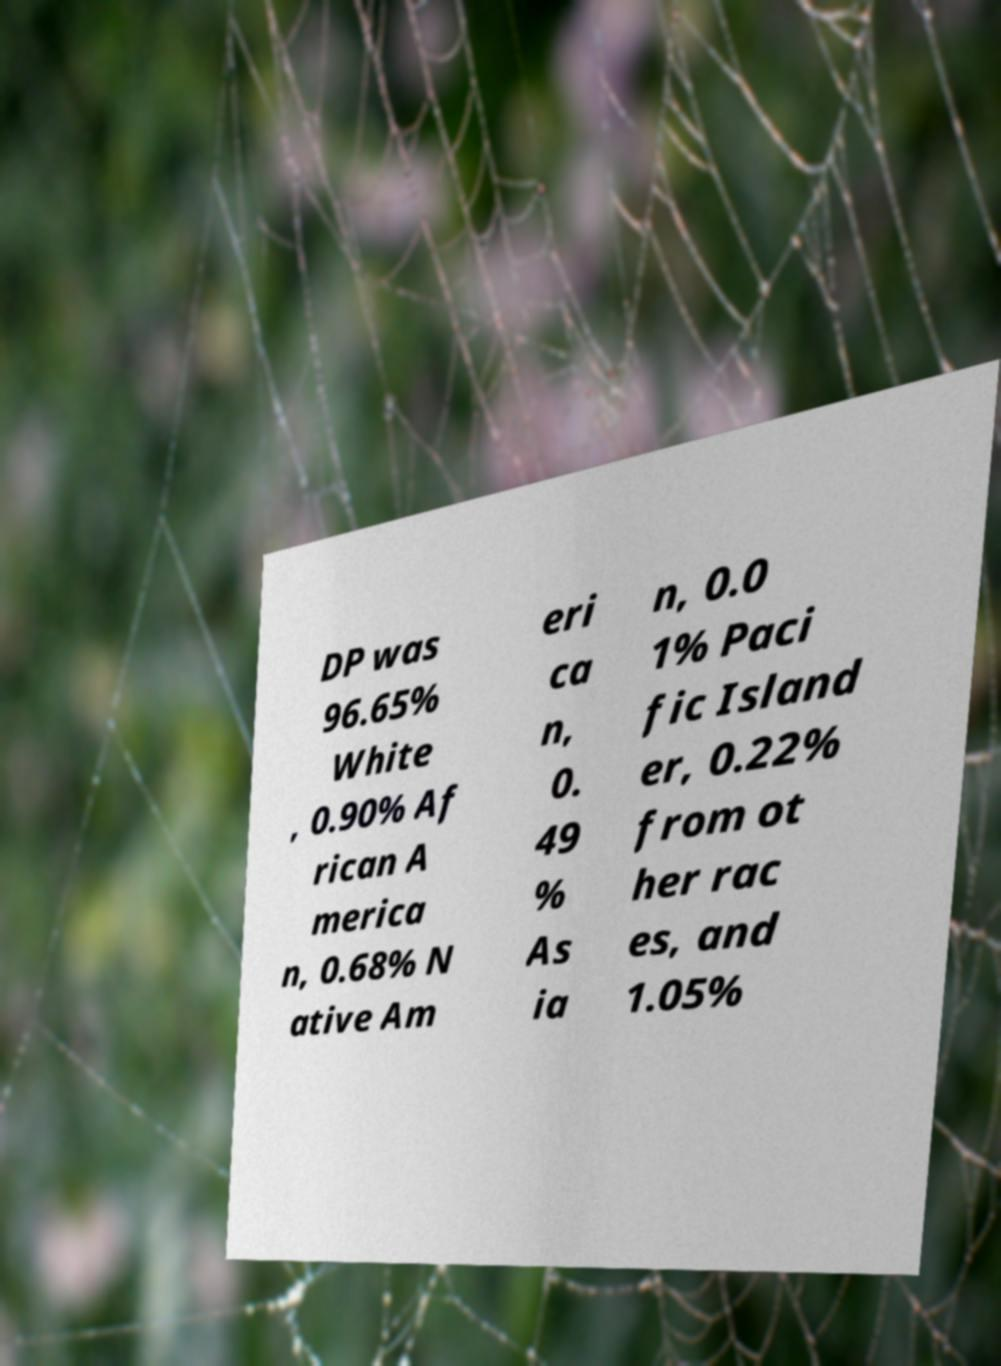Please read and relay the text visible in this image. What does it say? DP was 96.65% White , 0.90% Af rican A merica n, 0.68% N ative Am eri ca n, 0. 49 % As ia n, 0.0 1% Paci fic Island er, 0.22% from ot her rac es, and 1.05% 